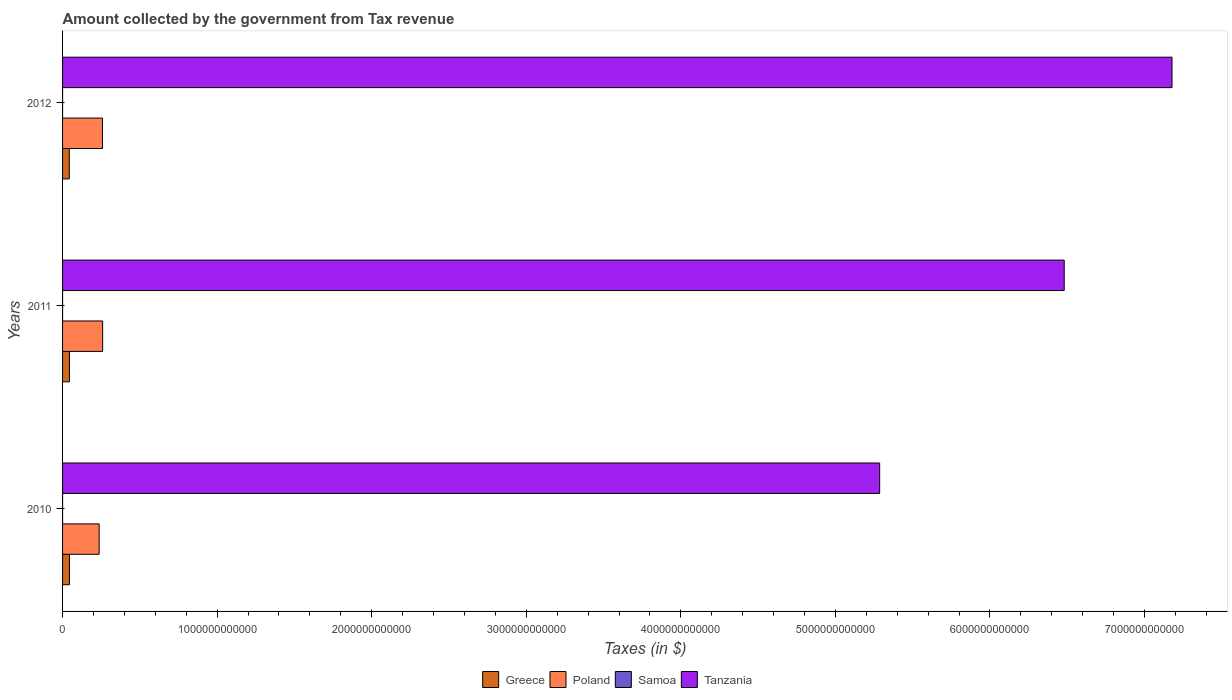Are the number of bars per tick equal to the number of legend labels?
Keep it short and to the point. Yes. Are the number of bars on each tick of the Y-axis equal?
Your answer should be very brief. Yes. How many bars are there on the 1st tick from the bottom?
Your answer should be very brief. 4. What is the label of the 1st group of bars from the top?
Keep it short and to the point. 2012. In how many cases, is the number of bars for a given year not equal to the number of legend labels?
Provide a succinct answer. 0. What is the amount collected by the government from tax revenue in Tanzania in 2012?
Make the answer very short. 7.18e+12. Across all years, what is the maximum amount collected by the government from tax revenue in Poland?
Provide a succinct answer. 2.59e+11. Across all years, what is the minimum amount collected by the government from tax revenue in Samoa?
Your response must be concise. 3.54e+05. In which year was the amount collected by the government from tax revenue in Poland minimum?
Your response must be concise. 2010. What is the total amount collected by the government from tax revenue in Greece in the graph?
Your response must be concise. 1.32e+11. What is the difference between the amount collected by the government from tax revenue in Tanzania in 2010 and that in 2011?
Your response must be concise. -1.19e+12. What is the difference between the amount collected by the government from tax revenue in Tanzania in 2011 and the amount collected by the government from tax revenue in Samoa in 2012?
Offer a terse response. 6.48e+12. What is the average amount collected by the government from tax revenue in Tanzania per year?
Provide a succinct answer. 6.31e+12. In the year 2012, what is the difference between the amount collected by the government from tax revenue in Tanzania and amount collected by the government from tax revenue in Samoa?
Your answer should be compact. 7.18e+12. In how many years, is the amount collected by the government from tax revenue in Poland greater than 3600000000000 $?
Your response must be concise. 0. What is the ratio of the amount collected by the government from tax revenue in Poland in 2011 to that in 2012?
Provide a succinct answer. 1. What is the difference between the highest and the second highest amount collected by the government from tax revenue in Tanzania?
Provide a short and direct response. 6.97e+11. What is the difference between the highest and the lowest amount collected by the government from tax revenue in Poland?
Provide a short and direct response. 2.27e+1. In how many years, is the amount collected by the government from tax revenue in Poland greater than the average amount collected by the government from tax revenue in Poland taken over all years?
Keep it short and to the point. 2. What does the 1st bar from the top in 2011 represents?
Offer a very short reply. Tanzania. What does the 3rd bar from the bottom in 2012 represents?
Your response must be concise. Samoa. Is it the case that in every year, the sum of the amount collected by the government from tax revenue in Greece and amount collected by the government from tax revenue in Poland is greater than the amount collected by the government from tax revenue in Tanzania?
Your answer should be very brief. No. How many bars are there?
Offer a very short reply. 12. How many years are there in the graph?
Your response must be concise. 3. What is the difference between two consecutive major ticks on the X-axis?
Your response must be concise. 1.00e+12. Does the graph contain any zero values?
Your response must be concise. No. Does the graph contain grids?
Offer a terse response. No. Where does the legend appear in the graph?
Your answer should be compact. Bottom center. How are the legend labels stacked?
Ensure brevity in your answer.  Horizontal. What is the title of the graph?
Your answer should be very brief. Amount collected by the government from Tax revenue. What is the label or title of the X-axis?
Your answer should be very brief. Taxes (in $). What is the label or title of the Y-axis?
Make the answer very short. Years. What is the Taxes (in $) of Greece in 2010?
Ensure brevity in your answer.  4.44e+1. What is the Taxes (in $) of Poland in 2010?
Provide a short and direct response. 2.37e+11. What is the Taxes (in $) of Samoa in 2010?
Offer a very short reply. 3.54e+05. What is the Taxes (in $) in Tanzania in 2010?
Your answer should be very brief. 5.29e+12. What is the Taxes (in $) in Greece in 2011?
Your response must be concise. 4.45e+1. What is the Taxes (in $) of Poland in 2011?
Offer a very short reply. 2.59e+11. What is the Taxes (in $) of Samoa in 2011?
Provide a short and direct response. 3.62e+05. What is the Taxes (in $) in Tanzania in 2011?
Provide a short and direct response. 6.48e+12. What is the Taxes (in $) in Greece in 2012?
Make the answer very short. 4.35e+1. What is the Taxes (in $) of Poland in 2012?
Offer a terse response. 2.58e+11. What is the Taxes (in $) of Samoa in 2012?
Make the answer very short. 3.61e+05. What is the Taxes (in $) of Tanzania in 2012?
Your answer should be compact. 7.18e+12. Across all years, what is the maximum Taxes (in $) in Greece?
Ensure brevity in your answer.  4.45e+1. Across all years, what is the maximum Taxes (in $) of Poland?
Make the answer very short. 2.59e+11. Across all years, what is the maximum Taxes (in $) in Samoa?
Give a very brief answer. 3.62e+05. Across all years, what is the maximum Taxes (in $) in Tanzania?
Provide a short and direct response. 7.18e+12. Across all years, what is the minimum Taxes (in $) in Greece?
Your answer should be very brief. 4.35e+1. Across all years, what is the minimum Taxes (in $) in Poland?
Ensure brevity in your answer.  2.37e+11. Across all years, what is the minimum Taxes (in $) in Samoa?
Give a very brief answer. 3.54e+05. Across all years, what is the minimum Taxes (in $) in Tanzania?
Give a very brief answer. 5.29e+12. What is the total Taxes (in $) in Greece in the graph?
Make the answer very short. 1.32e+11. What is the total Taxes (in $) of Poland in the graph?
Make the answer very short. 7.54e+11. What is the total Taxes (in $) of Samoa in the graph?
Offer a very short reply. 1.08e+06. What is the total Taxes (in $) of Tanzania in the graph?
Offer a terse response. 1.89e+13. What is the difference between the Taxes (in $) of Greece in 2010 and that in 2011?
Offer a terse response. -2.50e+07. What is the difference between the Taxes (in $) of Poland in 2010 and that in 2011?
Keep it short and to the point. -2.27e+1. What is the difference between the Taxes (in $) of Samoa in 2010 and that in 2011?
Give a very brief answer. -7573.96. What is the difference between the Taxes (in $) of Tanzania in 2010 and that in 2011?
Your answer should be very brief. -1.19e+12. What is the difference between the Taxes (in $) in Greece in 2010 and that in 2012?
Offer a terse response. 9.25e+08. What is the difference between the Taxes (in $) of Poland in 2010 and that in 2012?
Your response must be concise. -2.17e+1. What is the difference between the Taxes (in $) of Samoa in 2010 and that in 2012?
Give a very brief answer. -6495.3. What is the difference between the Taxes (in $) of Tanzania in 2010 and that in 2012?
Keep it short and to the point. -1.89e+12. What is the difference between the Taxes (in $) of Greece in 2011 and that in 2012?
Offer a very short reply. 9.50e+08. What is the difference between the Taxes (in $) of Poland in 2011 and that in 2012?
Make the answer very short. 9.58e+08. What is the difference between the Taxes (in $) of Samoa in 2011 and that in 2012?
Ensure brevity in your answer.  1078.66. What is the difference between the Taxes (in $) of Tanzania in 2011 and that in 2012?
Ensure brevity in your answer.  -6.97e+11. What is the difference between the Taxes (in $) in Greece in 2010 and the Taxes (in $) in Poland in 2011?
Your answer should be compact. -2.15e+11. What is the difference between the Taxes (in $) of Greece in 2010 and the Taxes (in $) of Samoa in 2011?
Keep it short and to the point. 4.44e+1. What is the difference between the Taxes (in $) of Greece in 2010 and the Taxes (in $) of Tanzania in 2011?
Provide a short and direct response. -6.44e+12. What is the difference between the Taxes (in $) of Poland in 2010 and the Taxes (in $) of Samoa in 2011?
Ensure brevity in your answer.  2.37e+11. What is the difference between the Taxes (in $) in Poland in 2010 and the Taxes (in $) in Tanzania in 2011?
Your answer should be compact. -6.24e+12. What is the difference between the Taxes (in $) in Samoa in 2010 and the Taxes (in $) in Tanzania in 2011?
Provide a short and direct response. -6.48e+12. What is the difference between the Taxes (in $) in Greece in 2010 and the Taxes (in $) in Poland in 2012?
Give a very brief answer. -2.14e+11. What is the difference between the Taxes (in $) of Greece in 2010 and the Taxes (in $) of Samoa in 2012?
Give a very brief answer. 4.44e+1. What is the difference between the Taxes (in $) of Greece in 2010 and the Taxes (in $) of Tanzania in 2012?
Give a very brief answer. -7.13e+12. What is the difference between the Taxes (in $) of Poland in 2010 and the Taxes (in $) of Samoa in 2012?
Make the answer very short. 2.37e+11. What is the difference between the Taxes (in $) of Poland in 2010 and the Taxes (in $) of Tanzania in 2012?
Make the answer very short. -6.94e+12. What is the difference between the Taxes (in $) of Samoa in 2010 and the Taxes (in $) of Tanzania in 2012?
Your response must be concise. -7.18e+12. What is the difference between the Taxes (in $) in Greece in 2011 and the Taxes (in $) in Poland in 2012?
Offer a very short reply. -2.14e+11. What is the difference between the Taxes (in $) of Greece in 2011 and the Taxes (in $) of Samoa in 2012?
Your answer should be compact. 4.45e+1. What is the difference between the Taxes (in $) in Greece in 2011 and the Taxes (in $) in Tanzania in 2012?
Your response must be concise. -7.13e+12. What is the difference between the Taxes (in $) in Poland in 2011 and the Taxes (in $) in Samoa in 2012?
Provide a succinct answer. 2.59e+11. What is the difference between the Taxes (in $) of Poland in 2011 and the Taxes (in $) of Tanzania in 2012?
Give a very brief answer. -6.92e+12. What is the difference between the Taxes (in $) in Samoa in 2011 and the Taxes (in $) in Tanzania in 2012?
Provide a succinct answer. -7.18e+12. What is the average Taxes (in $) in Greece per year?
Make the answer very short. 4.41e+1. What is the average Taxes (in $) of Poland per year?
Your answer should be very brief. 2.51e+11. What is the average Taxes (in $) of Samoa per year?
Keep it short and to the point. 3.59e+05. What is the average Taxes (in $) of Tanzania per year?
Your answer should be compact. 6.31e+12. In the year 2010, what is the difference between the Taxes (in $) of Greece and Taxes (in $) of Poland?
Make the answer very short. -1.92e+11. In the year 2010, what is the difference between the Taxes (in $) of Greece and Taxes (in $) of Samoa?
Ensure brevity in your answer.  4.44e+1. In the year 2010, what is the difference between the Taxes (in $) of Greece and Taxes (in $) of Tanzania?
Your response must be concise. -5.24e+12. In the year 2010, what is the difference between the Taxes (in $) of Poland and Taxes (in $) of Samoa?
Give a very brief answer. 2.37e+11. In the year 2010, what is the difference between the Taxes (in $) in Poland and Taxes (in $) in Tanzania?
Your response must be concise. -5.05e+12. In the year 2010, what is the difference between the Taxes (in $) of Samoa and Taxes (in $) of Tanzania?
Provide a short and direct response. -5.29e+12. In the year 2011, what is the difference between the Taxes (in $) in Greece and Taxes (in $) in Poland?
Keep it short and to the point. -2.15e+11. In the year 2011, what is the difference between the Taxes (in $) in Greece and Taxes (in $) in Samoa?
Provide a short and direct response. 4.45e+1. In the year 2011, what is the difference between the Taxes (in $) of Greece and Taxes (in $) of Tanzania?
Offer a very short reply. -6.44e+12. In the year 2011, what is the difference between the Taxes (in $) of Poland and Taxes (in $) of Samoa?
Your answer should be very brief. 2.59e+11. In the year 2011, what is the difference between the Taxes (in $) of Poland and Taxes (in $) of Tanzania?
Give a very brief answer. -6.22e+12. In the year 2011, what is the difference between the Taxes (in $) of Samoa and Taxes (in $) of Tanzania?
Keep it short and to the point. -6.48e+12. In the year 2012, what is the difference between the Taxes (in $) of Greece and Taxes (in $) of Poland?
Provide a succinct answer. -2.15e+11. In the year 2012, what is the difference between the Taxes (in $) in Greece and Taxes (in $) in Samoa?
Your answer should be compact. 4.35e+1. In the year 2012, what is the difference between the Taxes (in $) in Greece and Taxes (in $) in Tanzania?
Provide a short and direct response. -7.13e+12. In the year 2012, what is the difference between the Taxes (in $) in Poland and Taxes (in $) in Samoa?
Your response must be concise. 2.58e+11. In the year 2012, what is the difference between the Taxes (in $) of Poland and Taxes (in $) of Tanzania?
Keep it short and to the point. -6.92e+12. In the year 2012, what is the difference between the Taxes (in $) in Samoa and Taxes (in $) in Tanzania?
Make the answer very short. -7.18e+12. What is the ratio of the Taxes (in $) in Greece in 2010 to that in 2011?
Provide a succinct answer. 1. What is the ratio of the Taxes (in $) in Poland in 2010 to that in 2011?
Provide a short and direct response. 0.91. What is the ratio of the Taxes (in $) of Samoa in 2010 to that in 2011?
Offer a very short reply. 0.98. What is the ratio of the Taxes (in $) of Tanzania in 2010 to that in 2011?
Provide a succinct answer. 0.82. What is the ratio of the Taxes (in $) of Greece in 2010 to that in 2012?
Provide a succinct answer. 1.02. What is the ratio of the Taxes (in $) in Poland in 2010 to that in 2012?
Offer a very short reply. 0.92. What is the ratio of the Taxes (in $) in Tanzania in 2010 to that in 2012?
Provide a short and direct response. 0.74. What is the ratio of the Taxes (in $) of Greece in 2011 to that in 2012?
Ensure brevity in your answer.  1.02. What is the ratio of the Taxes (in $) in Tanzania in 2011 to that in 2012?
Keep it short and to the point. 0.9. What is the difference between the highest and the second highest Taxes (in $) in Greece?
Offer a very short reply. 2.50e+07. What is the difference between the highest and the second highest Taxes (in $) in Poland?
Give a very brief answer. 9.58e+08. What is the difference between the highest and the second highest Taxes (in $) of Samoa?
Your answer should be compact. 1078.66. What is the difference between the highest and the second highest Taxes (in $) in Tanzania?
Offer a terse response. 6.97e+11. What is the difference between the highest and the lowest Taxes (in $) of Greece?
Provide a short and direct response. 9.50e+08. What is the difference between the highest and the lowest Taxes (in $) of Poland?
Your answer should be very brief. 2.27e+1. What is the difference between the highest and the lowest Taxes (in $) of Samoa?
Your response must be concise. 7573.96. What is the difference between the highest and the lowest Taxes (in $) of Tanzania?
Your response must be concise. 1.89e+12. 